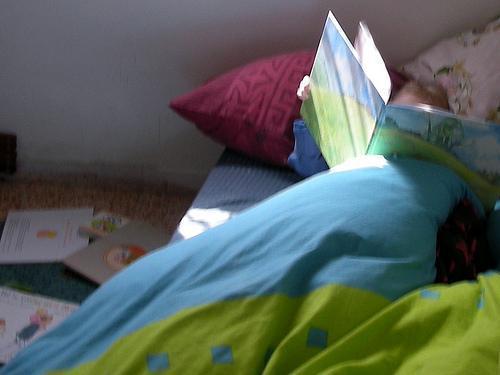How many books are there?
Give a very brief answer. 4. 